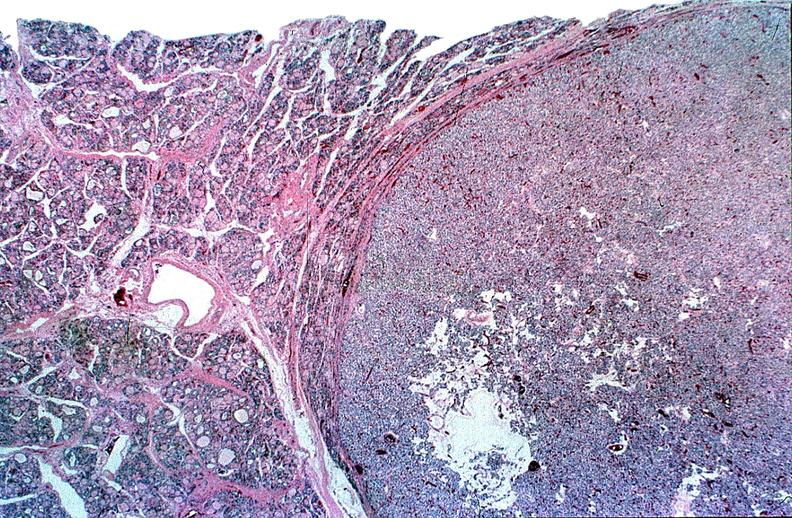s endocrine present?
Answer the question using a single word or phrase. Yes 